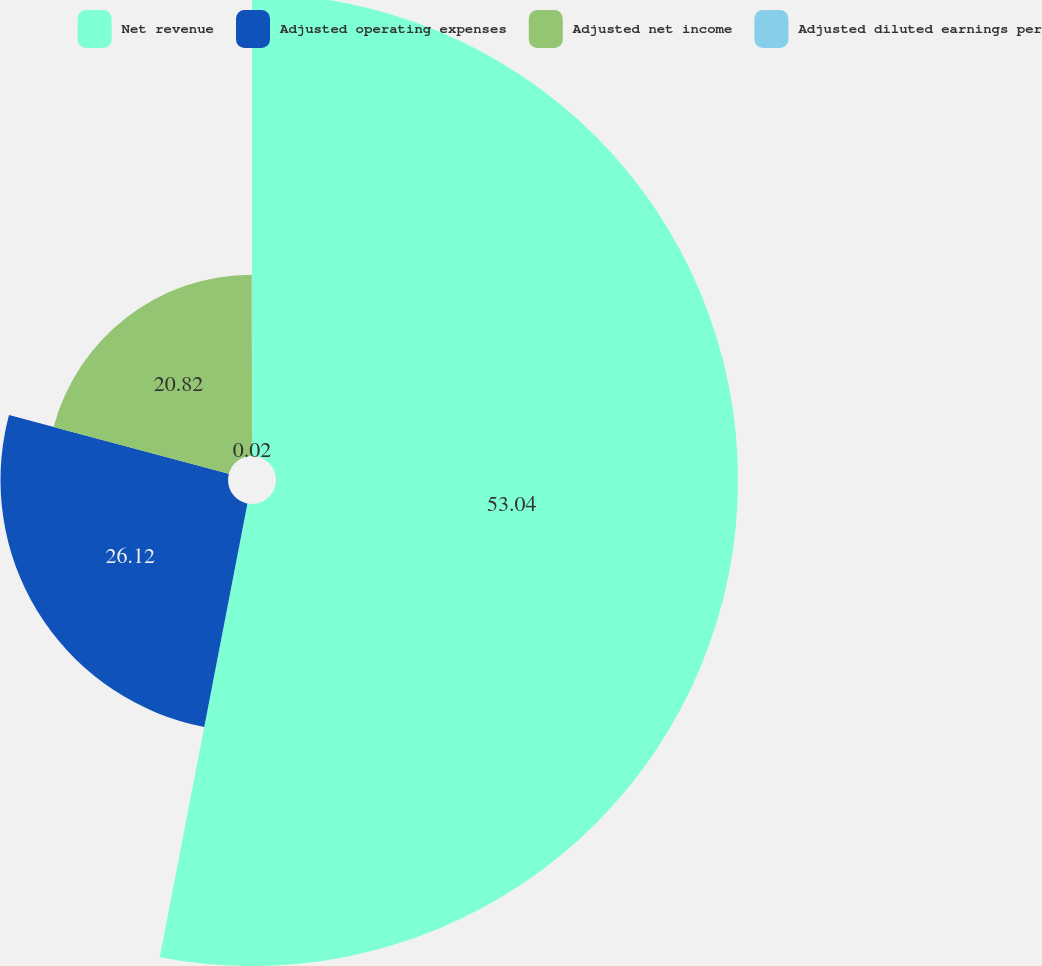<chart> <loc_0><loc_0><loc_500><loc_500><pie_chart><fcel>Net revenue<fcel>Adjusted operating expenses<fcel>Adjusted net income<fcel>Adjusted diluted earnings per<nl><fcel>53.04%<fcel>26.12%<fcel>20.82%<fcel>0.02%<nl></chart> 